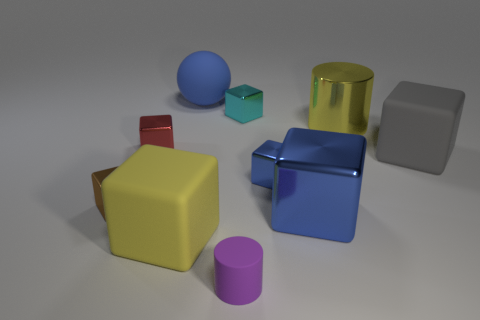Does the tiny object that is on the left side of the small red metallic thing have the same material as the big cylinder?
Your answer should be compact. Yes. Are there fewer large things that are to the right of the small blue object than things on the left side of the big gray rubber object?
Make the answer very short. Yes. Is there anything else that is the same shape as the tiny red thing?
Ensure brevity in your answer.  Yes. There is a object that is the same color as the big metallic cylinder; what is it made of?
Ensure brevity in your answer.  Rubber. There is a matte thing that is to the right of the yellow object that is to the right of the tiny purple cylinder; how many purple objects are to the right of it?
Your answer should be very brief. 0. There is a matte cylinder; how many small metallic objects are in front of it?
Offer a very short reply. 0. How many large gray blocks have the same material as the tiny purple object?
Keep it short and to the point. 1. There is a big cylinder that is the same material as the red cube; what color is it?
Ensure brevity in your answer.  Yellow. What is the material of the small object that is behind the big yellow object to the right of the rubber thing behind the large gray thing?
Provide a short and direct response. Metal. Do the cylinder that is to the left of the cyan thing and the red object have the same size?
Keep it short and to the point. Yes. 